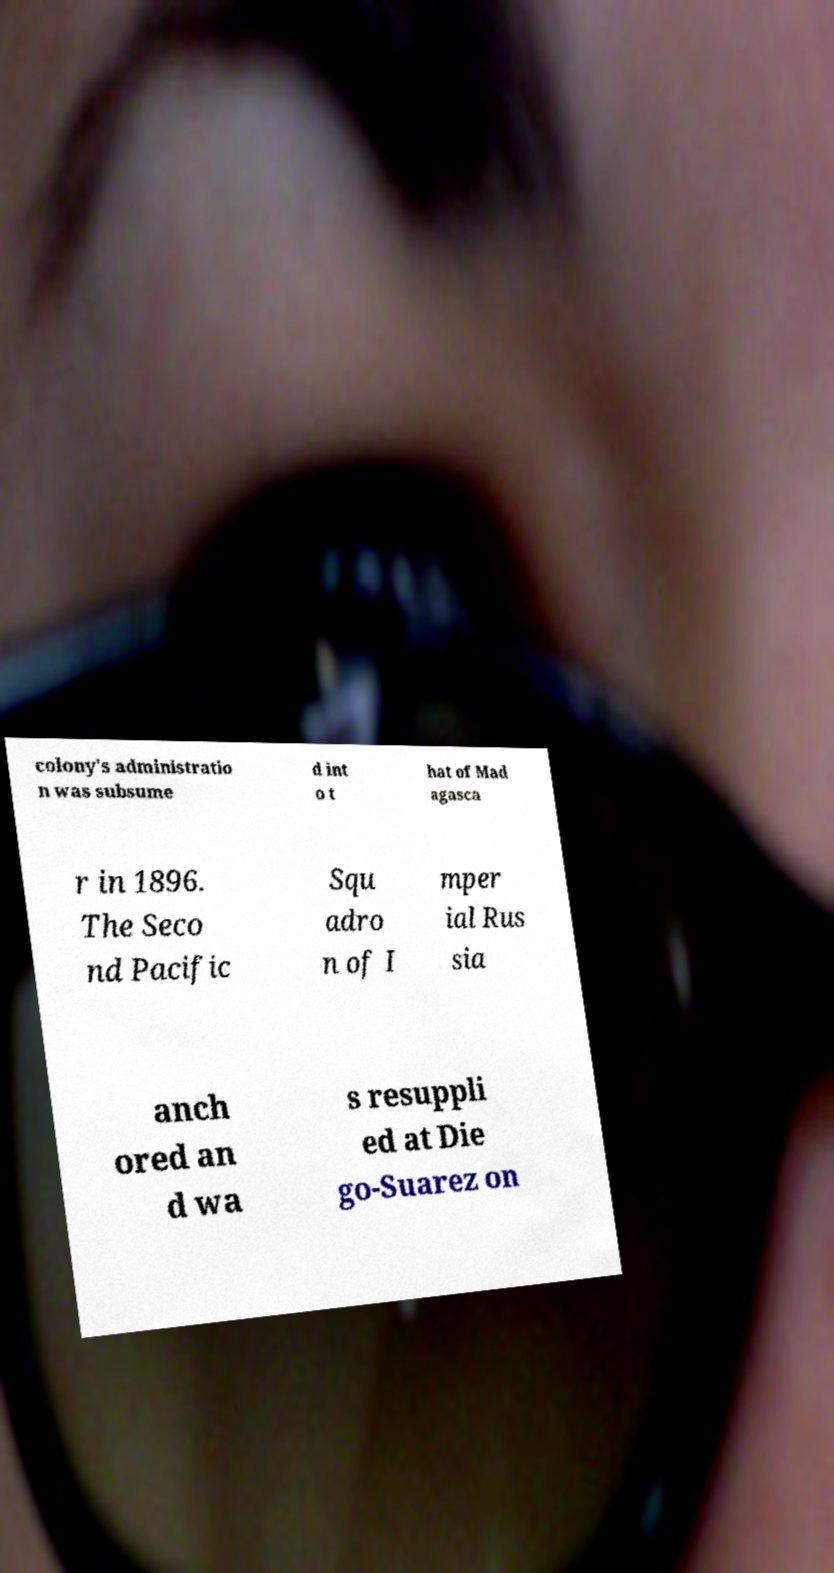What messages or text are displayed in this image? I need them in a readable, typed format. colony's administratio n was subsume d int o t hat of Mad agasca r in 1896. The Seco nd Pacific Squ adro n of I mper ial Rus sia anch ored an d wa s resuppli ed at Die go-Suarez on 